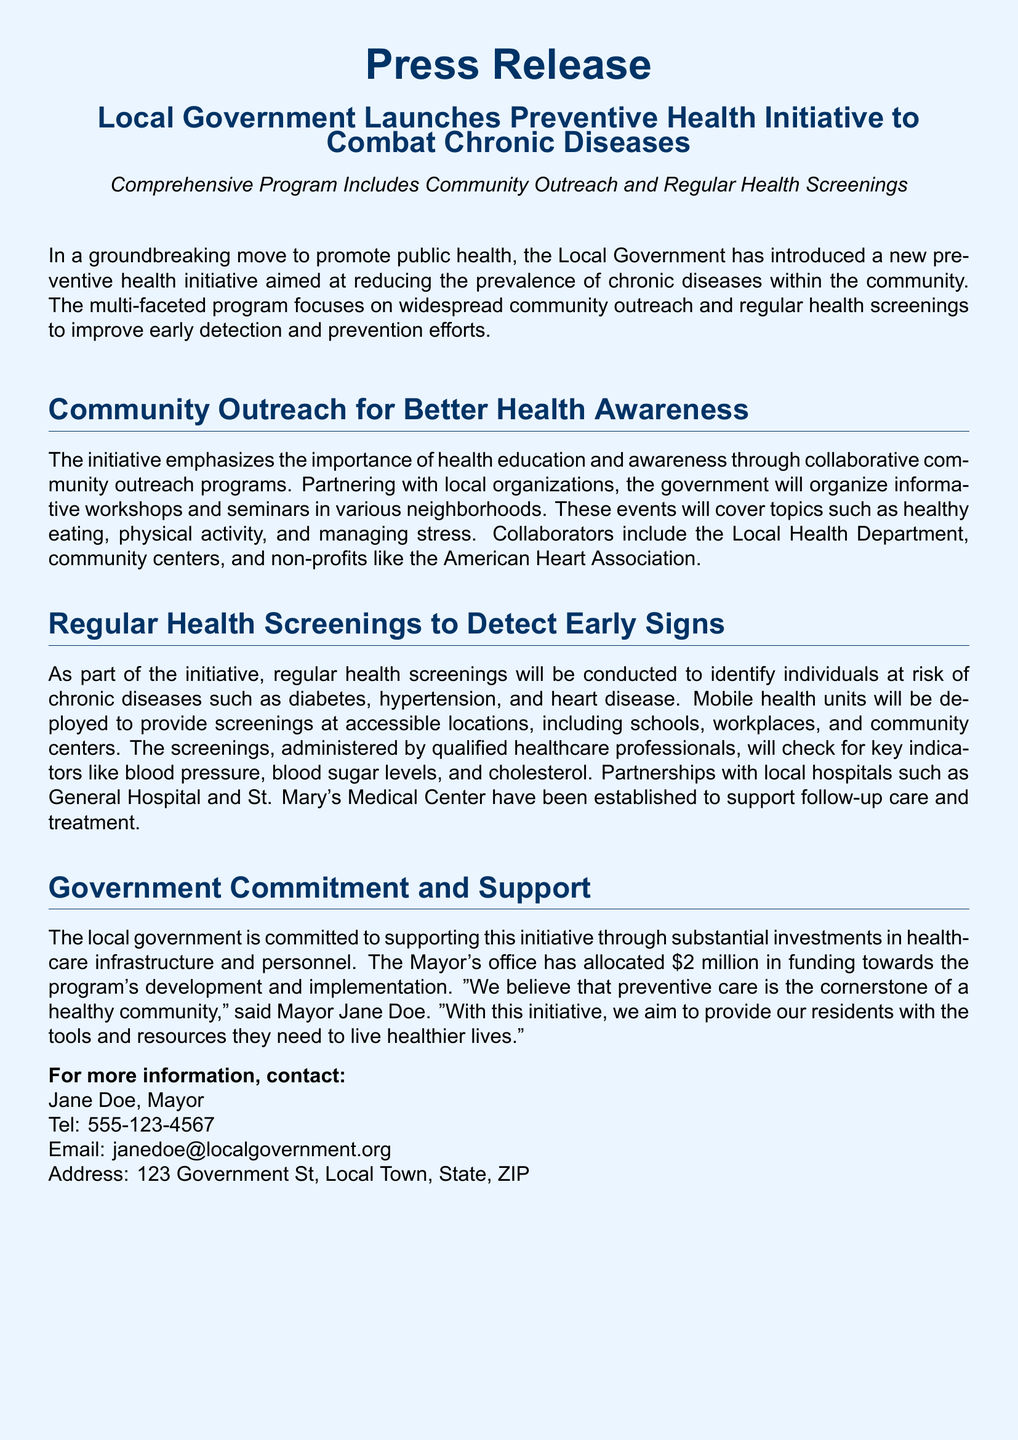What is the title of the initiative? The title of the initiative is specified in the heading of the press release.
Answer: Preventive Health Initiative to Combat Chronic Diseases How much funding has been allocated for the initiative? The funding amount is clearly stated in the section discussing government commitment.
Answer: $2 million Who is the Mayor mentioned in the document? The Mayor's name is provided in the section about government support.
Answer: Jane Doe What types of chronic diseases are targeted by the initiative? These diseases are listed in the description of the health screenings section.
Answer: Diabetes, hypertension, and heart disease Which organization is partnering with the local government for outreach programs? The document mentions specific partners in the community outreach section.
Answer: American Heart Association What will the health screenings check for? The document lists key indicators that will be checked during the screenings.
Answer: Blood pressure, blood sugar levels, and cholesterol Where will mobile health units provide screenings? The locations for the screenings are outlined in the health screenings section.
Answer: Schools, workplaces, and community centers What is the primary goal of the initiative? The goal is stated in the initial paragraph of the press release.
Answer: Reduce the prevalence of chronic diseases 